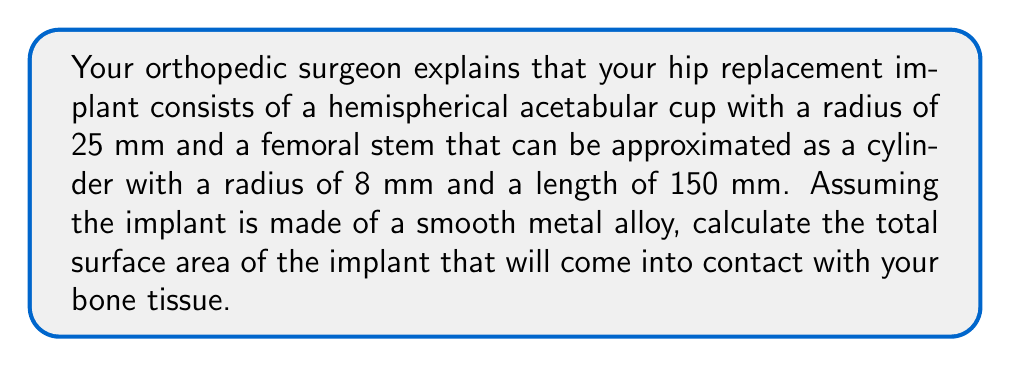Can you solve this math problem? Let's break this problem down into steps:

1. Calculate the surface area of the hemispherical acetabular cup:
   The surface area of a hemisphere is given by the formula:
   $$A_{hemisphere} = 2\pi r^2$$
   Where $r$ is the radius of the hemisphere.
   $$A_{hemisphere} = 2\pi (25 \text{ mm})^2 = 3926.99 \text{ mm}^2$$

2. Calculate the surface area of the cylindrical femoral stem:
   The surface area of a cylinder (excluding the bases) is given by:
   $$A_{cylinder} = 2\pi rh$$
   Where $r$ is the radius of the base and $h$ is the height of the cylinder.
   $$A_{cylinder} = 2\pi (8 \text{ mm})(150 \text{ mm}) = 7539.82 \text{ mm}^2$$

3. Add the surface areas of both components:
   $$A_{total} = A_{hemisphere} + A_{cylinder}$$
   $$A_{total} = 3926.99 \text{ mm}^2 + 7539.82 \text{ mm}^2 = 11466.81 \text{ mm}^2$$

4. Convert the result to cm² for a more manageable unit:
   $$A_{total} = 11466.81 \text{ mm}^2 \times \frac{1 \text{ cm}^2}{100 \text{ mm}^2} = 114.67 \text{ cm}^2$$
Answer: The total surface area of the hip replacement implant that will come into contact with bone tissue is approximately 114.67 cm². 